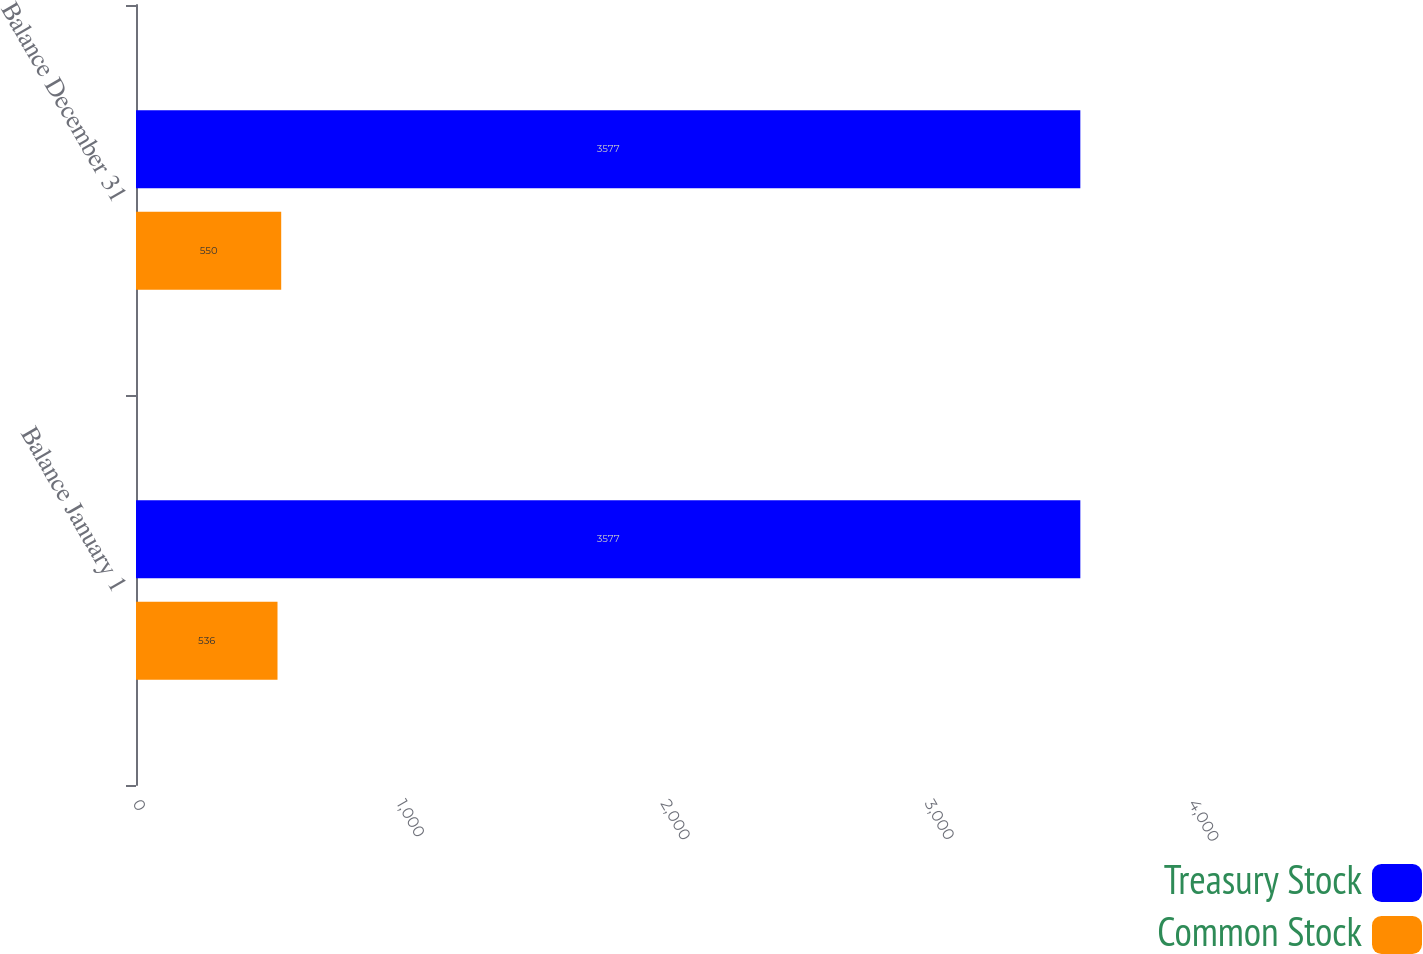<chart> <loc_0><loc_0><loc_500><loc_500><stacked_bar_chart><ecel><fcel>Balance January 1<fcel>Balance December 31<nl><fcel>Treasury Stock<fcel>3577<fcel>3577<nl><fcel>Common Stock<fcel>536<fcel>550<nl></chart> 